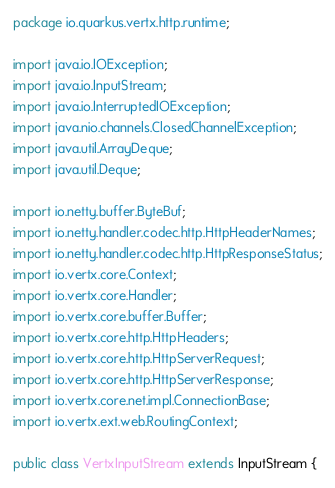Convert code to text. <code><loc_0><loc_0><loc_500><loc_500><_Java_>package io.quarkus.vertx.http.runtime;

import java.io.IOException;
import java.io.InputStream;
import java.io.InterruptedIOException;
import java.nio.channels.ClosedChannelException;
import java.util.ArrayDeque;
import java.util.Deque;

import io.netty.buffer.ByteBuf;
import io.netty.handler.codec.http.HttpHeaderNames;
import io.netty.handler.codec.http.HttpResponseStatus;
import io.vertx.core.Context;
import io.vertx.core.Handler;
import io.vertx.core.buffer.Buffer;
import io.vertx.core.http.HttpHeaders;
import io.vertx.core.http.HttpServerRequest;
import io.vertx.core.http.HttpServerResponse;
import io.vertx.core.net.impl.ConnectionBase;
import io.vertx.ext.web.RoutingContext;

public class VertxInputStream extends InputStream {
</code> 